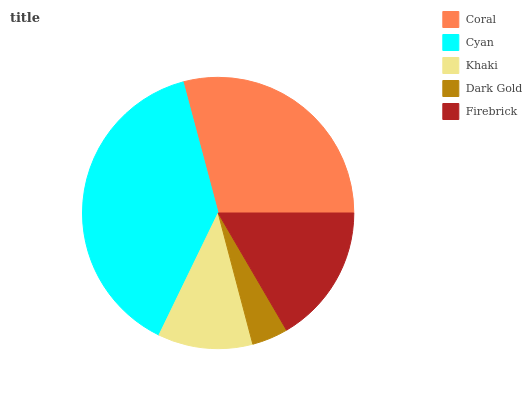Is Dark Gold the minimum?
Answer yes or no. Yes. Is Cyan the maximum?
Answer yes or no. Yes. Is Khaki the minimum?
Answer yes or no. No. Is Khaki the maximum?
Answer yes or no. No. Is Cyan greater than Khaki?
Answer yes or no. Yes. Is Khaki less than Cyan?
Answer yes or no. Yes. Is Khaki greater than Cyan?
Answer yes or no. No. Is Cyan less than Khaki?
Answer yes or no. No. Is Firebrick the high median?
Answer yes or no. Yes. Is Firebrick the low median?
Answer yes or no. Yes. Is Coral the high median?
Answer yes or no. No. Is Dark Gold the low median?
Answer yes or no. No. 